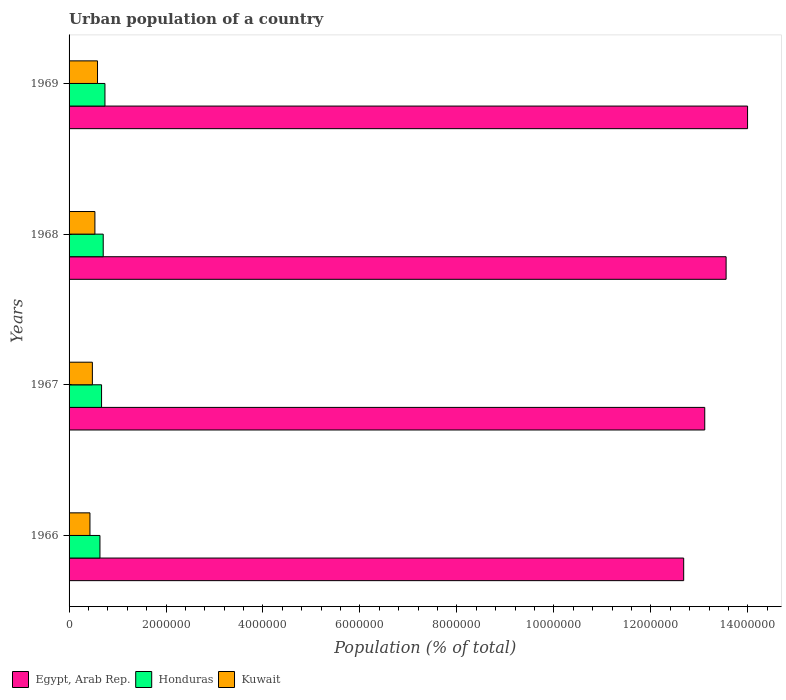How many different coloured bars are there?
Provide a succinct answer. 3. How many groups of bars are there?
Keep it short and to the point. 4. Are the number of bars per tick equal to the number of legend labels?
Your answer should be compact. Yes. How many bars are there on the 3rd tick from the top?
Offer a terse response. 3. What is the label of the 4th group of bars from the top?
Offer a terse response. 1966. In how many cases, is the number of bars for a given year not equal to the number of legend labels?
Offer a very short reply. 0. What is the urban population in Egypt, Arab Rep. in 1968?
Offer a terse response. 1.36e+07. Across all years, what is the maximum urban population in Egypt, Arab Rep.?
Your answer should be very brief. 1.40e+07. Across all years, what is the minimum urban population in Kuwait?
Offer a terse response. 4.31e+05. In which year was the urban population in Kuwait maximum?
Provide a succinct answer. 1969. In which year was the urban population in Egypt, Arab Rep. minimum?
Offer a terse response. 1966. What is the total urban population in Honduras in the graph?
Offer a terse response. 2.75e+06. What is the difference between the urban population in Kuwait in 1967 and that in 1969?
Provide a succinct answer. -1.06e+05. What is the difference between the urban population in Egypt, Arab Rep. in 1966 and the urban population in Kuwait in 1968?
Give a very brief answer. 1.21e+07. What is the average urban population in Kuwait per year?
Your answer should be very brief. 5.08e+05. In the year 1966, what is the difference between the urban population in Egypt, Arab Rep. and urban population in Kuwait?
Make the answer very short. 1.22e+07. In how many years, is the urban population in Honduras greater than 5600000 %?
Your answer should be very brief. 0. What is the ratio of the urban population in Kuwait in 1968 to that in 1969?
Make the answer very short. 0.91. Is the urban population in Honduras in 1967 less than that in 1968?
Give a very brief answer. Yes. What is the difference between the highest and the second highest urban population in Honduras?
Make the answer very short. 3.57e+04. What is the difference between the highest and the lowest urban population in Kuwait?
Give a very brief answer. 1.56e+05. In how many years, is the urban population in Kuwait greater than the average urban population in Kuwait taken over all years?
Offer a very short reply. 2. What does the 1st bar from the top in 1969 represents?
Provide a short and direct response. Kuwait. What does the 1st bar from the bottom in 1966 represents?
Make the answer very short. Egypt, Arab Rep. Is it the case that in every year, the sum of the urban population in Egypt, Arab Rep. and urban population in Kuwait is greater than the urban population in Honduras?
Keep it short and to the point. Yes. How many bars are there?
Your answer should be compact. 12. Are all the bars in the graph horizontal?
Give a very brief answer. Yes. How many years are there in the graph?
Your answer should be very brief. 4. How are the legend labels stacked?
Your answer should be very brief. Horizontal. What is the title of the graph?
Provide a succinct answer. Urban population of a country. What is the label or title of the X-axis?
Make the answer very short. Population (% of total). What is the Population (% of total) of Egypt, Arab Rep. in 1966?
Give a very brief answer. 1.27e+07. What is the Population (% of total) of Honduras in 1966?
Your answer should be compact. 6.37e+05. What is the Population (% of total) of Kuwait in 1966?
Provide a succinct answer. 4.31e+05. What is the Population (% of total) of Egypt, Arab Rep. in 1967?
Offer a terse response. 1.31e+07. What is the Population (% of total) of Honduras in 1967?
Provide a short and direct response. 6.70e+05. What is the Population (% of total) in Kuwait in 1967?
Make the answer very short. 4.81e+05. What is the Population (% of total) of Egypt, Arab Rep. in 1968?
Offer a very short reply. 1.36e+07. What is the Population (% of total) of Honduras in 1968?
Offer a very short reply. 7.04e+05. What is the Population (% of total) in Kuwait in 1968?
Keep it short and to the point. 5.33e+05. What is the Population (% of total) in Egypt, Arab Rep. in 1969?
Your answer should be compact. 1.40e+07. What is the Population (% of total) of Honduras in 1969?
Provide a succinct answer. 7.40e+05. What is the Population (% of total) of Kuwait in 1969?
Keep it short and to the point. 5.87e+05. Across all years, what is the maximum Population (% of total) of Egypt, Arab Rep.?
Provide a succinct answer. 1.40e+07. Across all years, what is the maximum Population (% of total) of Honduras?
Offer a terse response. 7.40e+05. Across all years, what is the maximum Population (% of total) in Kuwait?
Ensure brevity in your answer.  5.87e+05. Across all years, what is the minimum Population (% of total) of Egypt, Arab Rep.?
Your answer should be compact. 1.27e+07. Across all years, what is the minimum Population (% of total) in Honduras?
Your response must be concise. 6.37e+05. Across all years, what is the minimum Population (% of total) of Kuwait?
Keep it short and to the point. 4.31e+05. What is the total Population (% of total) of Egypt, Arab Rep. in the graph?
Your answer should be very brief. 5.33e+07. What is the total Population (% of total) in Honduras in the graph?
Give a very brief answer. 2.75e+06. What is the total Population (% of total) in Kuwait in the graph?
Keep it short and to the point. 2.03e+06. What is the difference between the Population (% of total) of Egypt, Arab Rep. in 1966 and that in 1967?
Ensure brevity in your answer.  -4.34e+05. What is the difference between the Population (% of total) in Honduras in 1966 and that in 1967?
Give a very brief answer. -3.31e+04. What is the difference between the Population (% of total) of Kuwait in 1966 and that in 1967?
Provide a short and direct response. -5.02e+04. What is the difference between the Population (% of total) in Egypt, Arab Rep. in 1966 and that in 1968?
Offer a terse response. -8.75e+05. What is the difference between the Population (% of total) of Honduras in 1966 and that in 1968?
Your answer should be compact. -6.72e+04. What is the difference between the Population (% of total) of Kuwait in 1966 and that in 1968?
Offer a terse response. -1.02e+05. What is the difference between the Population (% of total) in Egypt, Arab Rep. in 1966 and that in 1969?
Your answer should be compact. -1.32e+06. What is the difference between the Population (% of total) of Honduras in 1966 and that in 1969?
Your answer should be compact. -1.03e+05. What is the difference between the Population (% of total) of Kuwait in 1966 and that in 1969?
Ensure brevity in your answer.  -1.56e+05. What is the difference between the Population (% of total) in Egypt, Arab Rep. in 1967 and that in 1968?
Your response must be concise. -4.41e+05. What is the difference between the Population (% of total) in Honduras in 1967 and that in 1968?
Your answer should be compact. -3.41e+04. What is the difference between the Population (% of total) in Kuwait in 1967 and that in 1968?
Your answer should be compact. -5.20e+04. What is the difference between the Population (% of total) of Egypt, Arab Rep. in 1967 and that in 1969?
Keep it short and to the point. -8.83e+05. What is the difference between the Population (% of total) in Honduras in 1967 and that in 1969?
Your answer should be very brief. -6.98e+04. What is the difference between the Population (% of total) in Kuwait in 1967 and that in 1969?
Offer a very short reply. -1.06e+05. What is the difference between the Population (% of total) in Egypt, Arab Rep. in 1968 and that in 1969?
Make the answer very short. -4.43e+05. What is the difference between the Population (% of total) in Honduras in 1968 and that in 1969?
Keep it short and to the point. -3.57e+04. What is the difference between the Population (% of total) of Kuwait in 1968 and that in 1969?
Keep it short and to the point. -5.40e+04. What is the difference between the Population (% of total) in Egypt, Arab Rep. in 1966 and the Population (% of total) in Honduras in 1967?
Your answer should be compact. 1.20e+07. What is the difference between the Population (% of total) in Egypt, Arab Rep. in 1966 and the Population (% of total) in Kuwait in 1967?
Make the answer very short. 1.22e+07. What is the difference between the Population (% of total) of Honduras in 1966 and the Population (% of total) of Kuwait in 1967?
Provide a short and direct response. 1.56e+05. What is the difference between the Population (% of total) of Egypt, Arab Rep. in 1966 and the Population (% of total) of Honduras in 1968?
Your response must be concise. 1.20e+07. What is the difference between the Population (% of total) in Egypt, Arab Rep. in 1966 and the Population (% of total) in Kuwait in 1968?
Give a very brief answer. 1.21e+07. What is the difference between the Population (% of total) of Honduras in 1966 and the Population (% of total) of Kuwait in 1968?
Ensure brevity in your answer.  1.04e+05. What is the difference between the Population (% of total) in Egypt, Arab Rep. in 1966 and the Population (% of total) in Honduras in 1969?
Make the answer very short. 1.19e+07. What is the difference between the Population (% of total) in Egypt, Arab Rep. in 1966 and the Population (% of total) in Kuwait in 1969?
Keep it short and to the point. 1.21e+07. What is the difference between the Population (% of total) of Honduras in 1966 and the Population (% of total) of Kuwait in 1969?
Keep it short and to the point. 5.02e+04. What is the difference between the Population (% of total) in Egypt, Arab Rep. in 1967 and the Population (% of total) in Honduras in 1968?
Make the answer very short. 1.24e+07. What is the difference between the Population (% of total) of Egypt, Arab Rep. in 1967 and the Population (% of total) of Kuwait in 1968?
Your answer should be compact. 1.26e+07. What is the difference between the Population (% of total) in Honduras in 1967 and the Population (% of total) in Kuwait in 1968?
Ensure brevity in your answer.  1.37e+05. What is the difference between the Population (% of total) of Egypt, Arab Rep. in 1967 and the Population (% of total) of Honduras in 1969?
Give a very brief answer. 1.24e+07. What is the difference between the Population (% of total) of Egypt, Arab Rep. in 1967 and the Population (% of total) of Kuwait in 1969?
Ensure brevity in your answer.  1.25e+07. What is the difference between the Population (% of total) of Honduras in 1967 and the Population (% of total) of Kuwait in 1969?
Your response must be concise. 8.33e+04. What is the difference between the Population (% of total) in Egypt, Arab Rep. in 1968 and the Population (% of total) in Honduras in 1969?
Your response must be concise. 1.28e+07. What is the difference between the Population (% of total) in Egypt, Arab Rep. in 1968 and the Population (% of total) in Kuwait in 1969?
Your answer should be compact. 1.30e+07. What is the difference between the Population (% of total) of Honduras in 1968 and the Population (% of total) of Kuwait in 1969?
Ensure brevity in your answer.  1.17e+05. What is the average Population (% of total) of Egypt, Arab Rep. per year?
Ensure brevity in your answer.  1.33e+07. What is the average Population (% of total) in Honduras per year?
Provide a succinct answer. 6.88e+05. What is the average Population (% of total) in Kuwait per year?
Keep it short and to the point. 5.08e+05. In the year 1966, what is the difference between the Population (% of total) in Egypt, Arab Rep. and Population (% of total) in Honduras?
Make the answer very short. 1.20e+07. In the year 1966, what is the difference between the Population (% of total) in Egypt, Arab Rep. and Population (% of total) in Kuwait?
Your answer should be very brief. 1.22e+07. In the year 1966, what is the difference between the Population (% of total) of Honduras and Population (% of total) of Kuwait?
Provide a succinct answer. 2.06e+05. In the year 1967, what is the difference between the Population (% of total) in Egypt, Arab Rep. and Population (% of total) in Honduras?
Ensure brevity in your answer.  1.24e+07. In the year 1967, what is the difference between the Population (% of total) of Egypt, Arab Rep. and Population (% of total) of Kuwait?
Provide a short and direct response. 1.26e+07. In the year 1967, what is the difference between the Population (% of total) in Honduras and Population (% of total) in Kuwait?
Your answer should be compact. 1.89e+05. In the year 1968, what is the difference between the Population (% of total) in Egypt, Arab Rep. and Population (% of total) in Honduras?
Give a very brief answer. 1.28e+07. In the year 1968, what is the difference between the Population (% of total) of Egypt, Arab Rep. and Population (% of total) of Kuwait?
Your answer should be compact. 1.30e+07. In the year 1968, what is the difference between the Population (% of total) in Honduras and Population (% of total) in Kuwait?
Your response must be concise. 1.71e+05. In the year 1969, what is the difference between the Population (% of total) in Egypt, Arab Rep. and Population (% of total) in Honduras?
Provide a succinct answer. 1.33e+07. In the year 1969, what is the difference between the Population (% of total) in Egypt, Arab Rep. and Population (% of total) in Kuwait?
Offer a very short reply. 1.34e+07. In the year 1969, what is the difference between the Population (% of total) of Honduras and Population (% of total) of Kuwait?
Offer a terse response. 1.53e+05. What is the ratio of the Population (% of total) of Egypt, Arab Rep. in 1966 to that in 1967?
Offer a terse response. 0.97. What is the ratio of the Population (% of total) of Honduras in 1966 to that in 1967?
Offer a terse response. 0.95. What is the ratio of the Population (% of total) in Kuwait in 1966 to that in 1967?
Provide a succinct answer. 0.9. What is the ratio of the Population (% of total) in Egypt, Arab Rep. in 1966 to that in 1968?
Your answer should be very brief. 0.94. What is the ratio of the Population (% of total) in Honduras in 1966 to that in 1968?
Your response must be concise. 0.9. What is the ratio of the Population (% of total) in Kuwait in 1966 to that in 1968?
Your answer should be very brief. 0.81. What is the ratio of the Population (% of total) in Egypt, Arab Rep. in 1966 to that in 1969?
Give a very brief answer. 0.91. What is the ratio of the Population (% of total) of Honduras in 1966 to that in 1969?
Your answer should be compact. 0.86. What is the ratio of the Population (% of total) of Kuwait in 1966 to that in 1969?
Provide a succinct answer. 0.73. What is the ratio of the Population (% of total) of Egypt, Arab Rep. in 1967 to that in 1968?
Your answer should be very brief. 0.97. What is the ratio of the Population (% of total) of Honduras in 1967 to that in 1968?
Offer a very short reply. 0.95. What is the ratio of the Population (% of total) in Kuwait in 1967 to that in 1968?
Your response must be concise. 0.9. What is the ratio of the Population (% of total) in Egypt, Arab Rep. in 1967 to that in 1969?
Give a very brief answer. 0.94. What is the ratio of the Population (% of total) in Honduras in 1967 to that in 1969?
Provide a succinct answer. 0.91. What is the ratio of the Population (% of total) in Kuwait in 1967 to that in 1969?
Your answer should be very brief. 0.82. What is the ratio of the Population (% of total) in Egypt, Arab Rep. in 1968 to that in 1969?
Provide a short and direct response. 0.97. What is the ratio of the Population (% of total) in Honduras in 1968 to that in 1969?
Make the answer very short. 0.95. What is the ratio of the Population (% of total) of Kuwait in 1968 to that in 1969?
Ensure brevity in your answer.  0.91. What is the difference between the highest and the second highest Population (% of total) of Egypt, Arab Rep.?
Your response must be concise. 4.43e+05. What is the difference between the highest and the second highest Population (% of total) of Honduras?
Ensure brevity in your answer.  3.57e+04. What is the difference between the highest and the second highest Population (% of total) in Kuwait?
Give a very brief answer. 5.40e+04. What is the difference between the highest and the lowest Population (% of total) of Egypt, Arab Rep.?
Provide a succinct answer. 1.32e+06. What is the difference between the highest and the lowest Population (% of total) of Honduras?
Offer a terse response. 1.03e+05. What is the difference between the highest and the lowest Population (% of total) in Kuwait?
Offer a very short reply. 1.56e+05. 